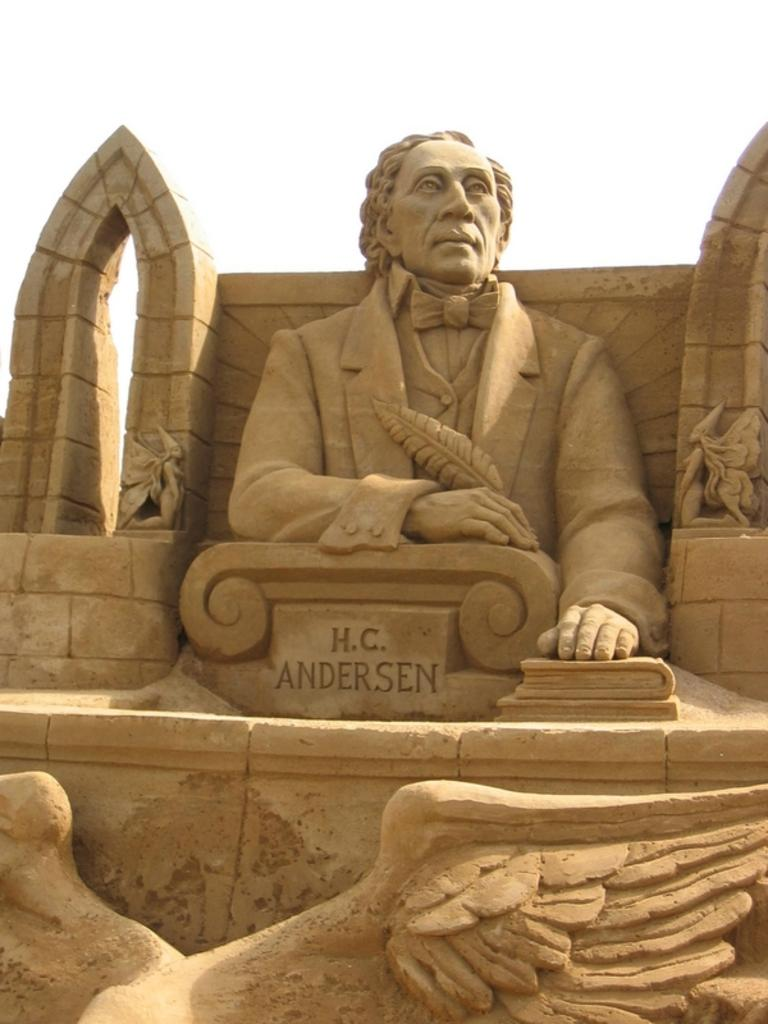What type of art is featured in the image? There are sculptures in the image. What type of architectural feature is visible in the image? There is a wall in the image. Can you describe the text that is present in the image? There is some text in the center of the image. What type of prose is being recited by the sculptures in the image? There is no indication in the image that the sculptures are reciting any prose. Can you tell me how many cannons are present in the image? There are no cannons present in the image. 